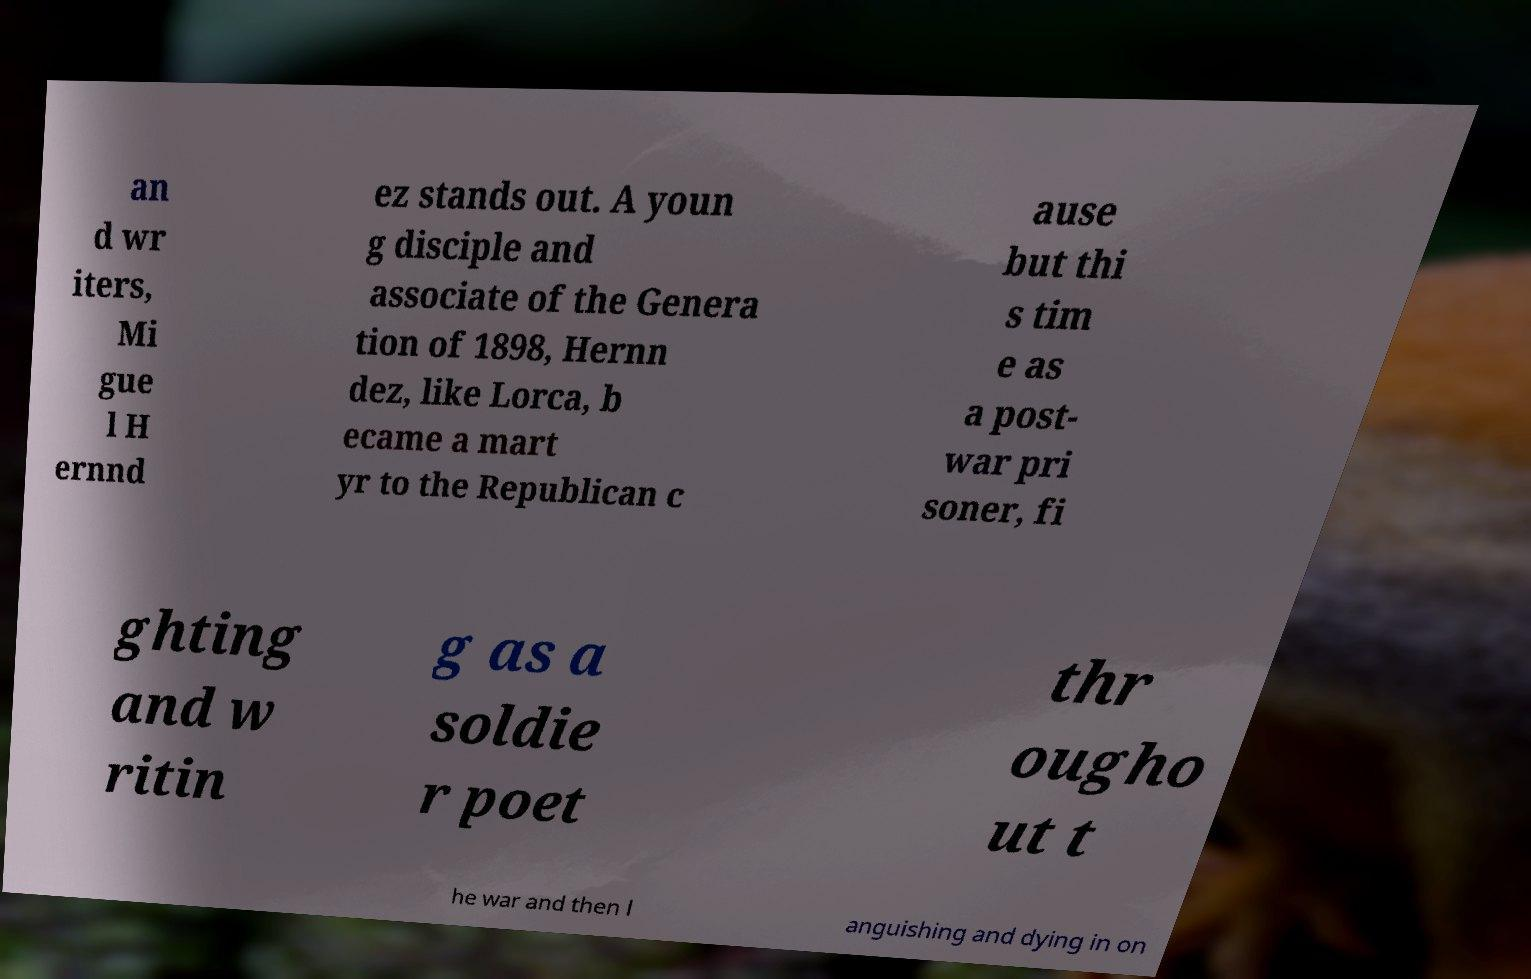Please identify and transcribe the text found in this image. an d wr iters, Mi gue l H ernnd ez stands out. A youn g disciple and associate of the Genera tion of 1898, Hernn dez, like Lorca, b ecame a mart yr to the Republican c ause but thi s tim e as a post- war pri soner, fi ghting and w ritin g as a soldie r poet thr ougho ut t he war and then l anguishing and dying in on 